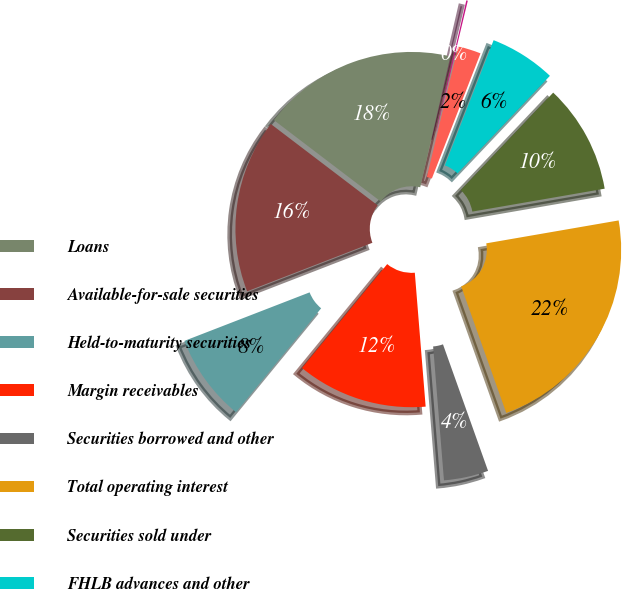<chart> <loc_0><loc_0><loc_500><loc_500><pie_chart><fcel>Loans<fcel>Available-for-sale securities<fcel>Held-to-maturity securities<fcel>Margin receivables<fcel>Securities borrowed and other<fcel>Total operating interest<fcel>Securities sold under<fcel>FHLB advances and other<fcel>Deposits<fcel>Customer payables and other<nl><fcel>18.25%<fcel>16.24%<fcel>8.19%<fcel>12.21%<fcel>4.16%<fcel>22.28%<fcel>10.2%<fcel>6.17%<fcel>2.15%<fcel>0.14%<nl></chart> 